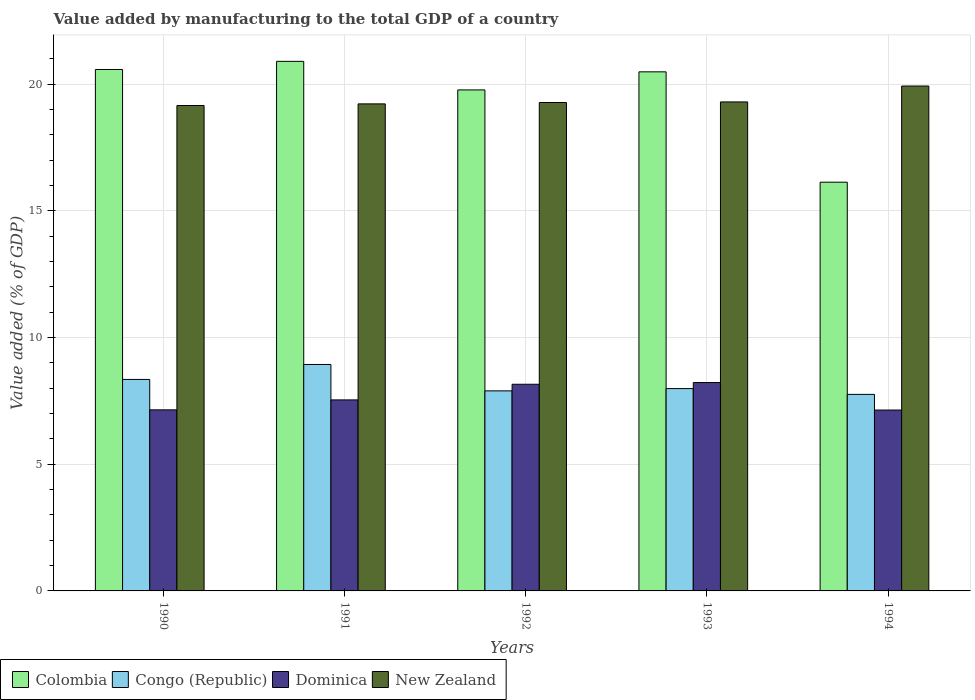How many different coloured bars are there?
Provide a short and direct response. 4. How many bars are there on the 4th tick from the left?
Your answer should be compact. 4. What is the value added by manufacturing to the total GDP in Colombia in 1990?
Keep it short and to the point. 20.58. Across all years, what is the maximum value added by manufacturing to the total GDP in Dominica?
Give a very brief answer. 8.22. Across all years, what is the minimum value added by manufacturing to the total GDP in Colombia?
Give a very brief answer. 16.13. In which year was the value added by manufacturing to the total GDP in Congo (Republic) maximum?
Your answer should be compact. 1991. What is the total value added by manufacturing to the total GDP in Dominica in the graph?
Keep it short and to the point. 38.2. What is the difference between the value added by manufacturing to the total GDP in Congo (Republic) in 1991 and that in 1992?
Offer a very short reply. 1.04. What is the difference between the value added by manufacturing to the total GDP in Congo (Republic) in 1994 and the value added by manufacturing to the total GDP in New Zealand in 1990?
Offer a very short reply. -11.4. What is the average value added by manufacturing to the total GDP in Congo (Republic) per year?
Keep it short and to the point. 8.18. In the year 1992, what is the difference between the value added by manufacturing to the total GDP in New Zealand and value added by manufacturing to the total GDP in Congo (Republic)?
Provide a succinct answer. 11.38. In how many years, is the value added by manufacturing to the total GDP in Congo (Republic) greater than 1 %?
Your response must be concise. 5. What is the ratio of the value added by manufacturing to the total GDP in New Zealand in 1991 to that in 1993?
Provide a short and direct response. 1. Is the value added by manufacturing to the total GDP in New Zealand in 1990 less than that in 1994?
Provide a short and direct response. Yes. What is the difference between the highest and the second highest value added by manufacturing to the total GDP in Colombia?
Ensure brevity in your answer.  0.32. What is the difference between the highest and the lowest value added by manufacturing to the total GDP in New Zealand?
Give a very brief answer. 0.77. In how many years, is the value added by manufacturing to the total GDP in Dominica greater than the average value added by manufacturing to the total GDP in Dominica taken over all years?
Ensure brevity in your answer.  2. What does the 3rd bar from the left in 1993 represents?
Offer a very short reply. Dominica. What does the 3rd bar from the right in 1993 represents?
Ensure brevity in your answer.  Congo (Republic). How many bars are there?
Make the answer very short. 20. Are all the bars in the graph horizontal?
Your response must be concise. No. What is the difference between two consecutive major ticks on the Y-axis?
Keep it short and to the point. 5. Are the values on the major ticks of Y-axis written in scientific E-notation?
Ensure brevity in your answer.  No. What is the title of the graph?
Your response must be concise. Value added by manufacturing to the total GDP of a country. Does "Least developed countries" appear as one of the legend labels in the graph?
Make the answer very short. No. What is the label or title of the X-axis?
Your answer should be very brief. Years. What is the label or title of the Y-axis?
Give a very brief answer. Value added (% of GDP). What is the Value added (% of GDP) in Colombia in 1990?
Your answer should be compact. 20.58. What is the Value added (% of GDP) of Congo (Republic) in 1990?
Provide a short and direct response. 8.35. What is the Value added (% of GDP) of Dominica in 1990?
Give a very brief answer. 7.15. What is the Value added (% of GDP) of New Zealand in 1990?
Offer a terse response. 19.16. What is the Value added (% of GDP) in Colombia in 1991?
Ensure brevity in your answer.  20.9. What is the Value added (% of GDP) of Congo (Republic) in 1991?
Offer a very short reply. 8.94. What is the Value added (% of GDP) in Dominica in 1991?
Your answer should be very brief. 7.54. What is the Value added (% of GDP) in New Zealand in 1991?
Ensure brevity in your answer.  19.22. What is the Value added (% of GDP) of Colombia in 1992?
Make the answer very short. 19.77. What is the Value added (% of GDP) of Congo (Republic) in 1992?
Offer a terse response. 7.9. What is the Value added (% of GDP) of Dominica in 1992?
Your answer should be very brief. 8.16. What is the Value added (% of GDP) of New Zealand in 1992?
Ensure brevity in your answer.  19.28. What is the Value added (% of GDP) of Colombia in 1993?
Your answer should be very brief. 20.49. What is the Value added (% of GDP) in Congo (Republic) in 1993?
Offer a very short reply. 7.99. What is the Value added (% of GDP) of Dominica in 1993?
Give a very brief answer. 8.22. What is the Value added (% of GDP) of New Zealand in 1993?
Your response must be concise. 19.3. What is the Value added (% of GDP) of Colombia in 1994?
Ensure brevity in your answer.  16.13. What is the Value added (% of GDP) in Congo (Republic) in 1994?
Provide a short and direct response. 7.76. What is the Value added (% of GDP) in Dominica in 1994?
Offer a very short reply. 7.14. What is the Value added (% of GDP) in New Zealand in 1994?
Offer a very short reply. 19.93. Across all years, what is the maximum Value added (% of GDP) in Colombia?
Your answer should be compact. 20.9. Across all years, what is the maximum Value added (% of GDP) in Congo (Republic)?
Keep it short and to the point. 8.94. Across all years, what is the maximum Value added (% of GDP) in Dominica?
Offer a very short reply. 8.22. Across all years, what is the maximum Value added (% of GDP) in New Zealand?
Offer a very short reply. 19.93. Across all years, what is the minimum Value added (% of GDP) of Colombia?
Keep it short and to the point. 16.13. Across all years, what is the minimum Value added (% of GDP) in Congo (Republic)?
Your answer should be compact. 7.76. Across all years, what is the minimum Value added (% of GDP) in Dominica?
Your response must be concise. 7.14. Across all years, what is the minimum Value added (% of GDP) of New Zealand?
Make the answer very short. 19.16. What is the total Value added (% of GDP) in Colombia in the graph?
Your answer should be very brief. 97.87. What is the total Value added (% of GDP) of Congo (Republic) in the graph?
Keep it short and to the point. 40.92. What is the total Value added (% of GDP) in Dominica in the graph?
Give a very brief answer. 38.2. What is the total Value added (% of GDP) in New Zealand in the graph?
Make the answer very short. 96.88. What is the difference between the Value added (% of GDP) in Colombia in 1990 and that in 1991?
Give a very brief answer. -0.32. What is the difference between the Value added (% of GDP) of Congo (Republic) in 1990 and that in 1991?
Your answer should be very brief. -0.59. What is the difference between the Value added (% of GDP) of Dominica in 1990 and that in 1991?
Ensure brevity in your answer.  -0.39. What is the difference between the Value added (% of GDP) of New Zealand in 1990 and that in 1991?
Keep it short and to the point. -0.06. What is the difference between the Value added (% of GDP) of Colombia in 1990 and that in 1992?
Keep it short and to the point. 0.81. What is the difference between the Value added (% of GDP) in Congo (Republic) in 1990 and that in 1992?
Provide a short and direct response. 0.45. What is the difference between the Value added (% of GDP) of Dominica in 1990 and that in 1992?
Ensure brevity in your answer.  -1.01. What is the difference between the Value added (% of GDP) of New Zealand in 1990 and that in 1992?
Provide a succinct answer. -0.12. What is the difference between the Value added (% of GDP) of Colombia in 1990 and that in 1993?
Provide a succinct answer. 0.09. What is the difference between the Value added (% of GDP) of Congo (Republic) in 1990 and that in 1993?
Your answer should be very brief. 0.36. What is the difference between the Value added (% of GDP) in Dominica in 1990 and that in 1993?
Offer a terse response. -1.08. What is the difference between the Value added (% of GDP) of New Zealand in 1990 and that in 1993?
Provide a succinct answer. -0.14. What is the difference between the Value added (% of GDP) of Colombia in 1990 and that in 1994?
Your response must be concise. 4.45. What is the difference between the Value added (% of GDP) in Congo (Republic) in 1990 and that in 1994?
Offer a terse response. 0.59. What is the difference between the Value added (% of GDP) in Dominica in 1990 and that in 1994?
Your answer should be compact. 0.01. What is the difference between the Value added (% of GDP) of New Zealand in 1990 and that in 1994?
Provide a succinct answer. -0.77. What is the difference between the Value added (% of GDP) in Colombia in 1991 and that in 1992?
Provide a short and direct response. 1.13. What is the difference between the Value added (% of GDP) of Congo (Republic) in 1991 and that in 1992?
Your response must be concise. 1.04. What is the difference between the Value added (% of GDP) of Dominica in 1991 and that in 1992?
Offer a very short reply. -0.62. What is the difference between the Value added (% of GDP) in New Zealand in 1991 and that in 1992?
Offer a terse response. -0.05. What is the difference between the Value added (% of GDP) in Colombia in 1991 and that in 1993?
Your answer should be compact. 0.41. What is the difference between the Value added (% of GDP) of Congo (Republic) in 1991 and that in 1993?
Provide a short and direct response. 0.95. What is the difference between the Value added (% of GDP) in Dominica in 1991 and that in 1993?
Give a very brief answer. -0.69. What is the difference between the Value added (% of GDP) in New Zealand in 1991 and that in 1993?
Provide a short and direct response. -0.08. What is the difference between the Value added (% of GDP) in Colombia in 1991 and that in 1994?
Your answer should be compact. 4.77. What is the difference between the Value added (% of GDP) of Congo (Republic) in 1991 and that in 1994?
Give a very brief answer. 1.18. What is the difference between the Value added (% of GDP) in New Zealand in 1991 and that in 1994?
Offer a very short reply. -0.7. What is the difference between the Value added (% of GDP) of Colombia in 1992 and that in 1993?
Your response must be concise. -0.71. What is the difference between the Value added (% of GDP) of Congo (Republic) in 1992 and that in 1993?
Keep it short and to the point. -0.09. What is the difference between the Value added (% of GDP) of Dominica in 1992 and that in 1993?
Make the answer very short. -0.07. What is the difference between the Value added (% of GDP) in New Zealand in 1992 and that in 1993?
Provide a short and direct response. -0.02. What is the difference between the Value added (% of GDP) of Colombia in 1992 and that in 1994?
Provide a short and direct response. 3.64. What is the difference between the Value added (% of GDP) of Congo (Republic) in 1992 and that in 1994?
Offer a very short reply. 0.14. What is the difference between the Value added (% of GDP) in Dominica in 1992 and that in 1994?
Offer a terse response. 1.02. What is the difference between the Value added (% of GDP) in New Zealand in 1992 and that in 1994?
Offer a terse response. -0.65. What is the difference between the Value added (% of GDP) of Colombia in 1993 and that in 1994?
Keep it short and to the point. 4.36. What is the difference between the Value added (% of GDP) in Congo (Republic) in 1993 and that in 1994?
Make the answer very short. 0.23. What is the difference between the Value added (% of GDP) of Dominica in 1993 and that in 1994?
Make the answer very short. 1.09. What is the difference between the Value added (% of GDP) in New Zealand in 1993 and that in 1994?
Offer a terse response. -0.63. What is the difference between the Value added (% of GDP) of Colombia in 1990 and the Value added (% of GDP) of Congo (Republic) in 1991?
Offer a very short reply. 11.64. What is the difference between the Value added (% of GDP) in Colombia in 1990 and the Value added (% of GDP) in Dominica in 1991?
Your answer should be compact. 13.04. What is the difference between the Value added (% of GDP) in Colombia in 1990 and the Value added (% of GDP) in New Zealand in 1991?
Provide a short and direct response. 1.36. What is the difference between the Value added (% of GDP) of Congo (Republic) in 1990 and the Value added (% of GDP) of Dominica in 1991?
Your answer should be compact. 0.81. What is the difference between the Value added (% of GDP) of Congo (Republic) in 1990 and the Value added (% of GDP) of New Zealand in 1991?
Offer a very short reply. -10.88. What is the difference between the Value added (% of GDP) of Dominica in 1990 and the Value added (% of GDP) of New Zealand in 1991?
Ensure brevity in your answer.  -12.08. What is the difference between the Value added (% of GDP) of Colombia in 1990 and the Value added (% of GDP) of Congo (Republic) in 1992?
Make the answer very short. 12.68. What is the difference between the Value added (% of GDP) of Colombia in 1990 and the Value added (% of GDP) of Dominica in 1992?
Ensure brevity in your answer.  12.42. What is the difference between the Value added (% of GDP) of Colombia in 1990 and the Value added (% of GDP) of New Zealand in 1992?
Your response must be concise. 1.3. What is the difference between the Value added (% of GDP) of Congo (Republic) in 1990 and the Value added (% of GDP) of Dominica in 1992?
Keep it short and to the point. 0.19. What is the difference between the Value added (% of GDP) in Congo (Republic) in 1990 and the Value added (% of GDP) in New Zealand in 1992?
Ensure brevity in your answer.  -10.93. What is the difference between the Value added (% of GDP) in Dominica in 1990 and the Value added (% of GDP) in New Zealand in 1992?
Keep it short and to the point. -12.13. What is the difference between the Value added (% of GDP) of Colombia in 1990 and the Value added (% of GDP) of Congo (Republic) in 1993?
Give a very brief answer. 12.59. What is the difference between the Value added (% of GDP) of Colombia in 1990 and the Value added (% of GDP) of Dominica in 1993?
Your answer should be compact. 12.36. What is the difference between the Value added (% of GDP) in Colombia in 1990 and the Value added (% of GDP) in New Zealand in 1993?
Provide a succinct answer. 1.28. What is the difference between the Value added (% of GDP) of Congo (Republic) in 1990 and the Value added (% of GDP) of Dominica in 1993?
Your answer should be compact. 0.12. What is the difference between the Value added (% of GDP) in Congo (Republic) in 1990 and the Value added (% of GDP) in New Zealand in 1993?
Provide a short and direct response. -10.95. What is the difference between the Value added (% of GDP) of Dominica in 1990 and the Value added (% of GDP) of New Zealand in 1993?
Ensure brevity in your answer.  -12.15. What is the difference between the Value added (% of GDP) in Colombia in 1990 and the Value added (% of GDP) in Congo (Republic) in 1994?
Your response must be concise. 12.82. What is the difference between the Value added (% of GDP) of Colombia in 1990 and the Value added (% of GDP) of Dominica in 1994?
Offer a very short reply. 13.44. What is the difference between the Value added (% of GDP) of Colombia in 1990 and the Value added (% of GDP) of New Zealand in 1994?
Provide a short and direct response. 0.65. What is the difference between the Value added (% of GDP) in Congo (Republic) in 1990 and the Value added (% of GDP) in Dominica in 1994?
Provide a succinct answer. 1.21. What is the difference between the Value added (% of GDP) in Congo (Republic) in 1990 and the Value added (% of GDP) in New Zealand in 1994?
Offer a very short reply. -11.58. What is the difference between the Value added (% of GDP) of Dominica in 1990 and the Value added (% of GDP) of New Zealand in 1994?
Offer a terse response. -12.78. What is the difference between the Value added (% of GDP) in Colombia in 1991 and the Value added (% of GDP) in Congo (Republic) in 1992?
Keep it short and to the point. 13. What is the difference between the Value added (% of GDP) of Colombia in 1991 and the Value added (% of GDP) of Dominica in 1992?
Your response must be concise. 12.74. What is the difference between the Value added (% of GDP) of Colombia in 1991 and the Value added (% of GDP) of New Zealand in 1992?
Ensure brevity in your answer.  1.62. What is the difference between the Value added (% of GDP) in Congo (Republic) in 1991 and the Value added (% of GDP) in Dominica in 1992?
Your answer should be compact. 0.78. What is the difference between the Value added (% of GDP) of Congo (Republic) in 1991 and the Value added (% of GDP) of New Zealand in 1992?
Offer a very short reply. -10.34. What is the difference between the Value added (% of GDP) in Dominica in 1991 and the Value added (% of GDP) in New Zealand in 1992?
Give a very brief answer. -11.74. What is the difference between the Value added (% of GDP) in Colombia in 1991 and the Value added (% of GDP) in Congo (Republic) in 1993?
Give a very brief answer. 12.91. What is the difference between the Value added (% of GDP) of Colombia in 1991 and the Value added (% of GDP) of Dominica in 1993?
Give a very brief answer. 12.68. What is the difference between the Value added (% of GDP) in Colombia in 1991 and the Value added (% of GDP) in New Zealand in 1993?
Offer a terse response. 1.6. What is the difference between the Value added (% of GDP) in Congo (Republic) in 1991 and the Value added (% of GDP) in Dominica in 1993?
Make the answer very short. 0.71. What is the difference between the Value added (% of GDP) of Congo (Republic) in 1991 and the Value added (% of GDP) of New Zealand in 1993?
Your response must be concise. -10.36. What is the difference between the Value added (% of GDP) in Dominica in 1991 and the Value added (% of GDP) in New Zealand in 1993?
Provide a short and direct response. -11.76. What is the difference between the Value added (% of GDP) of Colombia in 1991 and the Value added (% of GDP) of Congo (Republic) in 1994?
Provide a short and direct response. 13.14. What is the difference between the Value added (% of GDP) of Colombia in 1991 and the Value added (% of GDP) of Dominica in 1994?
Provide a succinct answer. 13.76. What is the difference between the Value added (% of GDP) of Colombia in 1991 and the Value added (% of GDP) of New Zealand in 1994?
Ensure brevity in your answer.  0.97. What is the difference between the Value added (% of GDP) of Congo (Republic) in 1991 and the Value added (% of GDP) of Dominica in 1994?
Give a very brief answer. 1.8. What is the difference between the Value added (% of GDP) in Congo (Republic) in 1991 and the Value added (% of GDP) in New Zealand in 1994?
Provide a succinct answer. -10.99. What is the difference between the Value added (% of GDP) of Dominica in 1991 and the Value added (% of GDP) of New Zealand in 1994?
Your answer should be very brief. -12.39. What is the difference between the Value added (% of GDP) of Colombia in 1992 and the Value added (% of GDP) of Congo (Republic) in 1993?
Offer a very short reply. 11.79. What is the difference between the Value added (% of GDP) in Colombia in 1992 and the Value added (% of GDP) in Dominica in 1993?
Ensure brevity in your answer.  11.55. What is the difference between the Value added (% of GDP) of Colombia in 1992 and the Value added (% of GDP) of New Zealand in 1993?
Offer a very short reply. 0.47. What is the difference between the Value added (% of GDP) of Congo (Republic) in 1992 and the Value added (% of GDP) of Dominica in 1993?
Make the answer very short. -0.33. What is the difference between the Value added (% of GDP) in Congo (Republic) in 1992 and the Value added (% of GDP) in New Zealand in 1993?
Ensure brevity in your answer.  -11.4. What is the difference between the Value added (% of GDP) in Dominica in 1992 and the Value added (% of GDP) in New Zealand in 1993?
Give a very brief answer. -11.14. What is the difference between the Value added (% of GDP) of Colombia in 1992 and the Value added (% of GDP) of Congo (Republic) in 1994?
Provide a short and direct response. 12.02. What is the difference between the Value added (% of GDP) in Colombia in 1992 and the Value added (% of GDP) in Dominica in 1994?
Your response must be concise. 12.63. What is the difference between the Value added (% of GDP) of Colombia in 1992 and the Value added (% of GDP) of New Zealand in 1994?
Provide a short and direct response. -0.15. What is the difference between the Value added (% of GDP) of Congo (Republic) in 1992 and the Value added (% of GDP) of Dominica in 1994?
Your response must be concise. 0.76. What is the difference between the Value added (% of GDP) of Congo (Republic) in 1992 and the Value added (% of GDP) of New Zealand in 1994?
Provide a short and direct response. -12.03. What is the difference between the Value added (% of GDP) in Dominica in 1992 and the Value added (% of GDP) in New Zealand in 1994?
Ensure brevity in your answer.  -11.77. What is the difference between the Value added (% of GDP) in Colombia in 1993 and the Value added (% of GDP) in Congo (Republic) in 1994?
Offer a very short reply. 12.73. What is the difference between the Value added (% of GDP) in Colombia in 1993 and the Value added (% of GDP) in Dominica in 1994?
Offer a very short reply. 13.35. What is the difference between the Value added (% of GDP) in Colombia in 1993 and the Value added (% of GDP) in New Zealand in 1994?
Offer a terse response. 0.56. What is the difference between the Value added (% of GDP) in Congo (Republic) in 1993 and the Value added (% of GDP) in Dominica in 1994?
Offer a terse response. 0.85. What is the difference between the Value added (% of GDP) in Congo (Republic) in 1993 and the Value added (% of GDP) in New Zealand in 1994?
Your response must be concise. -11.94. What is the difference between the Value added (% of GDP) in Dominica in 1993 and the Value added (% of GDP) in New Zealand in 1994?
Ensure brevity in your answer.  -11.7. What is the average Value added (% of GDP) of Colombia per year?
Offer a very short reply. 19.57. What is the average Value added (% of GDP) of Congo (Republic) per year?
Make the answer very short. 8.18. What is the average Value added (% of GDP) in Dominica per year?
Provide a succinct answer. 7.64. What is the average Value added (% of GDP) of New Zealand per year?
Ensure brevity in your answer.  19.38. In the year 1990, what is the difference between the Value added (% of GDP) of Colombia and Value added (% of GDP) of Congo (Republic)?
Provide a succinct answer. 12.23. In the year 1990, what is the difference between the Value added (% of GDP) in Colombia and Value added (% of GDP) in Dominica?
Keep it short and to the point. 13.43. In the year 1990, what is the difference between the Value added (% of GDP) in Colombia and Value added (% of GDP) in New Zealand?
Your answer should be very brief. 1.42. In the year 1990, what is the difference between the Value added (% of GDP) in Congo (Republic) and Value added (% of GDP) in Dominica?
Offer a terse response. 1.2. In the year 1990, what is the difference between the Value added (% of GDP) of Congo (Republic) and Value added (% of GDP) of New Zealand?
Your answer should be compact. -10.81. In the year 1990, what is the difference between the Value added (% of GDP) in Dominica and Value added (% of GDP) in New Zealand?
Give a very brief answer. -12.01. In the year 1991, what is the difference between the Value added (% of GDP) in Colombia and Value added (% of GDP) in Congo (Republic)?
Make the answer very short. 11.96. In the year 1991, what is the difference between the Value added (% of GDP) in Colombia and Value added (% of GDP) in Dominica?
Keep it short and to the point. 13.36. In the year 1991, what is the difference between the Value added (% of GDP) in Colombia and Value added (% of GDP) in New Zealand?
Your answer should be very brief. 1.68. In the year 1991, what is the difference between the Value added (% of GDP) of Congo (Republic) and Value added (% of GDP) of Dominica?
Make the answer very short. 1.4. In the year 1991, what is the difference between the Value added (% of GDP) in Congo (Republic) and Value added (% of GDP) in New Zealand?
Provide a short and direct response. -10.28. In the year 1991, what is the difference between the Value added (% of GDP) in Dominica and Value added (% of GDP) in New Zealand?
Give a very brief answer. -11.68. In the year 1992, what is the difference between the Value added (% of GDP) in Colombia and Value added (% of GDP) in Congo (Republic)?
Your answer should be compact. 11.88. In the year 1992, what is the difference between the Value added (% of GDP) in Colombia and Value added (% of GDP) in Dominica?
Provide a short and direct response. 11.62. In the year 1992, what is the difference between the Value added (% of GDP) in Colombia and Value added (% of GDP) in New Zealand?
Your response must be concise. 0.5. In the year 1992, what is the difference between the Value added (% of GDP) of Congo (Republic) and Value added (% of GDP) of Dominica?
Provide a short and direct response. -0.26. In the year 1992, what is the difference between the Value added (% of GDP) in Congo (Republic) and Value added (% of GDP) in New Zealand?
Your answer should be very brief. -11.38. In the year 1992, what is the difference between the Value added (% of GDP) in Dominica and Value added (% of GDP) in New Zealand?
Ensure brevity in your answer.  -11.12. In the year 1993, what is the difference between the Value added (% of GDP) in Colombia and Value added (% of GDP) in Congo (Republic)?
Keep it short and to the point. 12.5. In the year 1993, what is the difference between the Value added (% of GDP) in Colombia and Value added (% of GDP) in Dominica?
Your response must be concise. 12.26. In the year 1993, what is the difference between the Value added (% of GDP) of Colombia and Value added (% of GDP) of New Zealand?
Provide a succinct answer. 1.19. In the year 1993, what is the difference between the Value added (% of GDP) of Congo (Republic) and Value added (% of GDP) of Dominica?
Your response must be concise. -0.24. In the year 1993, what is the difference between the Value added (% of GDP) in Congo (Republic) and Value added (% of GDP) in New Zealand?
Keep it short and to the point. -11.31. In the year 1993, what is the difference between the Value added (% of GDP) in Dominica and Value added (% of GDP) in New Zealand?
Provide a succinct answer. -11.07. In the year 1994, what is the difference between the Value added (% of GDP) in Colombia and Value added (% of GDP) in Congo (Republic)?
Your answer should be compact. 8.37. In the year 1994, what is the difference between the Value added (% of GDP) of Colombia and Value added (% of GDP) of Dominica?
Offer a terse response. 8.99. In the year 1994, what is the difference between the Value added (% of GDP) in Colombia and Value added (% of GDP) in New Zealand?
Keep it short and to the point. -3.8. In the year 1994, what is the difference between the Value added (% of GDP) of Congo (Republic) and Value added (% of GDP) of Dominica?
Offer a very short reply. 0.62. In the year 1994, what is the difference between the Value added (% of GDP) in Congo (Republic) and Value added (% of GDP) in New Zealand?
Your answer should be very brief. -12.17. In the year 1994, what is the difference between the Value added (% of GDP) in Dominica and Value added (% of GDP) in New Zealand?
Your response must be concise. -12.79. What is the ratio of the Value added (% of GDP) in Colombia in 1990 to that in 1991?
Offer a terse response. 0.98. What is the ratio of the Value added (% of GDP) in Congo (Republic) in 1990 to that in 1991?
Make the answer very short. 0.93. What is the ratio of the Value added (% of GDP) in Dominica in 1990 to that in 1991?
Your answer should be very brief. 0.95. What is the ratio of the Value added (% of GDP) of Colombia in 1990 to that in 1992?
Make the answer very short. 1.04. What is the ratio of the Value added (% of GDP) of Congo (Republic) in 1990 to that in 1992?
Make the answer very short. 1.06. What is the ratio of the Value added (% of GDP) in Dominica in 1990 to that in 1992?
Provide a succinct answer. 0.88. What is the ratio of the Value added (% of GDP) in Congo (Republic) in 1990 to that in 1993?
Offer a very short reply. 1.05. What is the ratio of the Value added (% of GDP) in Dominica in 1990 to that in 1993?
Make the answer very short. 0.87. What is the ratio of the Value added (% of GDP) in New Zealand in 1990 to that in 1993?
Give a very brief answer. 0.99. What is the ratio of the Value added (% of GDP) in Colombia in 1990 to that in 1994?
Keep it short and to the point. 1.28. What is the ratio of the Value added (% of GDP) in Congo (Republic) in 1990 to that in 1994?
Your answer should be very brief. 1.08. What is the ratio of the Value added (% of GDP) in Dominica in 1990 to that in 1994?
Your answer should be compact. 1. What is the ratio of the Value added (% of GDP) in New Zealand in 1990 to that in 1994?
Offer a very short reply. 0.96. What is the ratio of the Value added (% of GDP) in Colombia in 1991 to that in 1992?
Keep it short and to the point. 1.06. What is the ratio of the Value added (% of GDP) of Congo (Republic) in 1991 to that in 1992?
Your response must be concise. 1.13. What is the ratio of the Value added (% of GDP) of Dominica in 1991 to that in 1992?
Offer a terse response. 0.92. What is the ratio of the Value added (% of GDP) in Colombia in 1991 to that in 1993?
Provide a succinct answer. 1.02. What is the ratio of the Value added (% of GDP) of Congo (Republic) in 1991 to that in 1993?
Offer a terse response. 1.12. What is the ratio of the Value added (% of GDP) in Colombia in 1991 to that in 1994?
Provide a short and direct response. 1.3. What is the ratio of the Value added (% of GDP) of Congo (Republic) in 1991 to that in 1994?
Your answer should be compact. 1.15. What is the ratio of the Value added (% of GDP) in Dominica in 1991 to that in 1994?
Give a very brief answer. 1.06. What is the ratio of the Value added (% of GDP) in New Zealand in 1991 to that in 1994?
Give a very brief answer. 0.96. What is the ratio of the Value added (% of GDP) of Colombia in 1992 to that in 1993?
Provide a short and direct response. 0.97. What is the ratio of the Value added (% of GDP) of Congo (Republic) in 1992 to that in 1993?
Offer a terse response. 0.99. What is the ratio of the Value added (% of GDP) of New Zealand in 1992 to that in 1993?
Ensure brevity in your answer.  1. What is the ratio of the Value added (% of GDP) of Colombia in 1992 to that in 1994?
Make the answer very short. 1.23. What is the ratio of the Value added (% of GDP) in Congo (Republic) in 1992 to that in 1994?
Your answer should be compact. 1.02. What is the ratio of the Value added (% of GDP) in Dominica in 1992 to that in 1994?
Your answer should be very brief. 1.14. What is the ratio of the Value added (% of GDP) of New Zealand in 1992 to that in 1994?
Make the answer very short. 0.97. What is the ratio of the Value added (% of GDP) of Colombia in 1993 to that in 1994?
Your answer should be compact. 1.27. What is the ratio of the Value added (% of GDP) of Congo (Republic) in 1993 to that in 1994?
Offer a terse response. 1.03. What is the ratio of the Value added (% of GDP) of Dominica in 1993 to that in 1994?
Make the answer very short. 1.15. What is the ratio of the Value added (% of GDP) of New Zealand in 1993 to that in 1994?
Keep it short and to the point. 0.97. What is the difference between the highest and the second highest Value added (% of GDP) of Colombia?
Your response must be concise. 0.32. What is the difference between the highest and the second highest Value added (% of GDP) in Congo (Republic)?
Offer a very short reply. 0.59. What is the difference between the highest and the second highest Value added (% of GDP) of Dominica?
Offer a terse response. 0.07. What is the difference between the highest and the second highest Value added (% of GDP) in New Zealand?
Your answer should be very brief. 0.63. What is the difference between the highest and the lowest Value added (% of GDP) in Colombia?
Ensure brevity in your answer.  4.77. What is the difference between the highest and the lowest Value added (% of GDP) in Congo (Republic)?
Your response must be concise. 1.18. What is the difference between the highest and the lowest Value added (% of GDP) of Dominica?
Your response must be concise. 1.09. What is the difference between the highest and the lowest Value added (% of GDP) in New Zealand?
Ensure brevity in your answer.  0.77. 